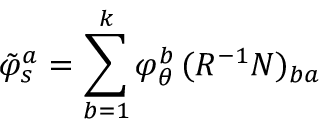Convert formula to latex. <formula><loc_0><loc_0><loc_500><loc_500>\tilde { \varphi } _ { s } ^ { a } = \sum _ { b = 1 } ^ { k } \varphi _ { \theta } ^ { b } \, ( R ^ { - 1 } N ) _ { b a }</formula> 